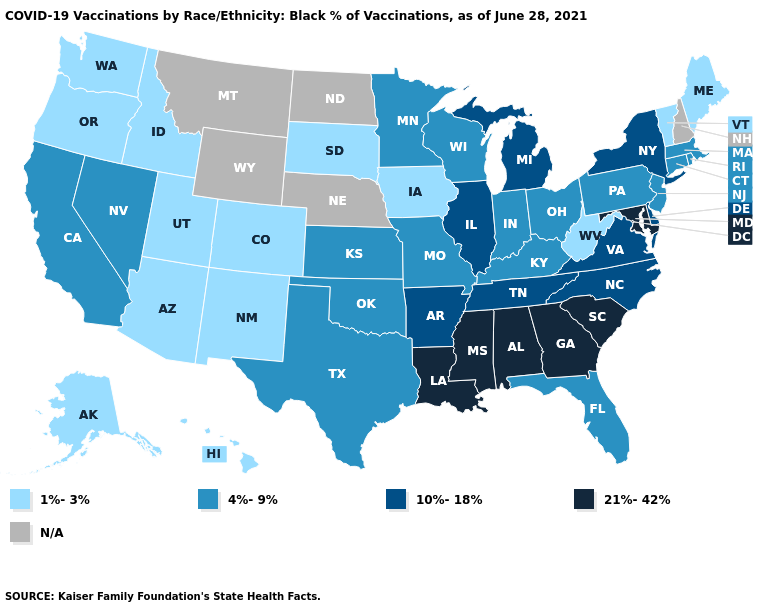Name the states that have a value in the range N/A?
Keep it brief. Montana, Nebraska, New Hampshire, North Dakota, Wyoming. What is the value of Colorado?
Quick response, please. 1%-3%. What is the value of New Jersey?
Answer briefly. 4%-9%. What is the lowest value in states that border Wyoming?
Answer briefly. 1%-3%. What is the lowest value in the South?
Quick response, please. 1%-3%. Name the states that have a value in the range 1%-3%?
Give a very brief answer. Alaska, Arizona, Colorado, Hawaii, Idaho, Iowa, Maine, New Mexico, Oregon, South Dakota, Utah, Vermont, Washington, West Virginia. Name the states that have a value in the range 21%-42%?
Answer briefly. Alabama, Georgia, Louisiana, Maryland, Mississippi, South Carolina. Which states have the lowest value in the West?
Give a very brief answer. Alaska, Arizona, Colorado, Hawaii, Idaho, New Mexico, Oregon, Utah, Washington. What is the value of Michigan?
Answer briefly. 10%-18%. What is the value of Arkansas?
Short answer required. 10%-18%. Which states have the lowest value in the USA?
Concise answer only. Alaska, Arizona, Colorado, Hawaii, Idaho, Iowa, Maine, New Mexico, Oregon, South Dakota, Utah, Vermont, Washington, West Virginia. Name the states that have a value in the range 21%-42%?
Answer briefly. Alabama, Georgia, Louisiana, Maryland, Mississippi, South Carolina. What is the lowest value in the USA?
Be succinct. 1%-3%. Name the states that have a value in the range 10%-18%?
Be succinct. Arkansas, Delaware, Illinois, Michigan, New York, North Carolina, Tennessee, Virginia. What is the value of South Carolina?
Write a very short answer. 21%-42%. 